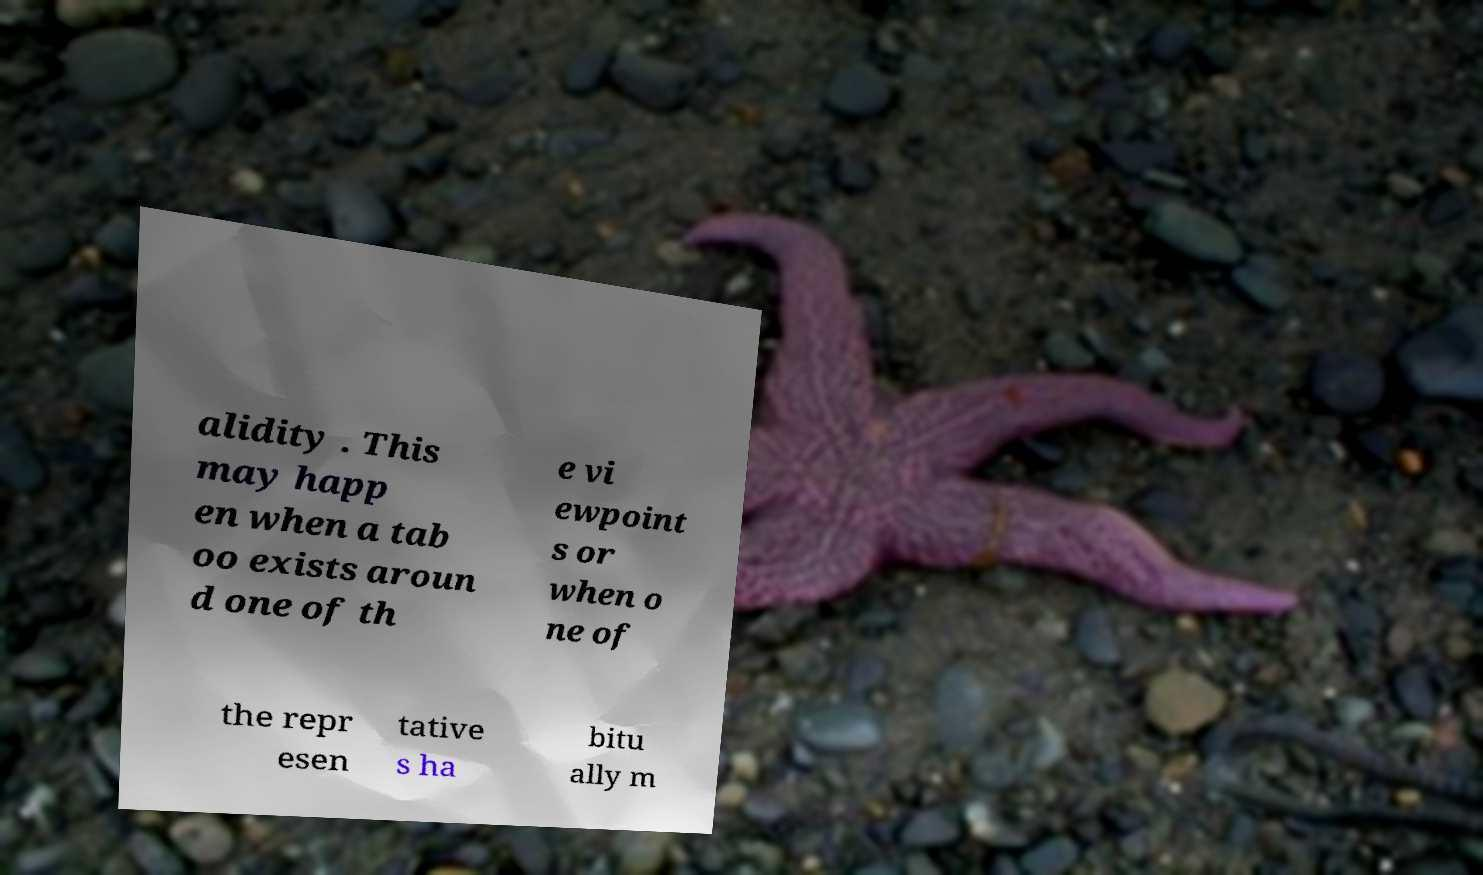Could you assist in decoding the text presented in this image and type it out clearly? alidity . This may happ en when a tab oo exists aroun d one of th e vi ewpoint s or when o ne of the repr esen tative s ha bitu ally m 